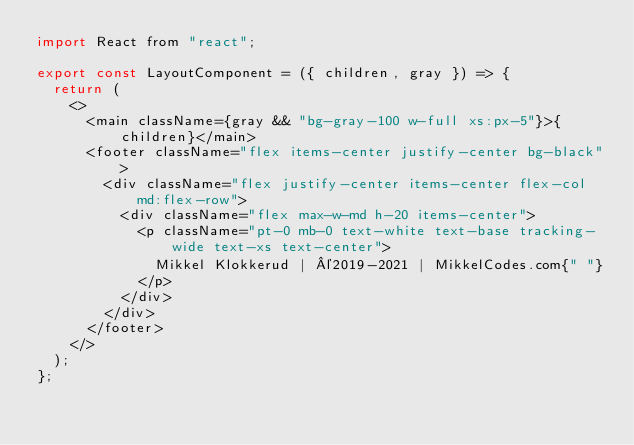<code> <loc_0><loc_0><loc_500><loc_500><_JavaScript_>import React from "react";

export const LayoutComponent = ({ children, gray }) => {
  return (
    <>
      <main className={gray && "bg-gray-100 w-full xs:px-5"}>{children}</main>
      <footer className="flex items-center justify-center bg-black">
        <div className="flex justify-center items-center flex-col md:flex-row">
          <div className="flex max-w-md h-20 items-center">
            <p className="pt-0 mb-0 text-white text-base tracking-wide text-xs text-center">
              Mikkel Klokkerud | ©2019-2021 | MikkelCodes.com{" "}
            </p>
          </div>
        </div>
      </footer>
    </>
  );
};
</code> 